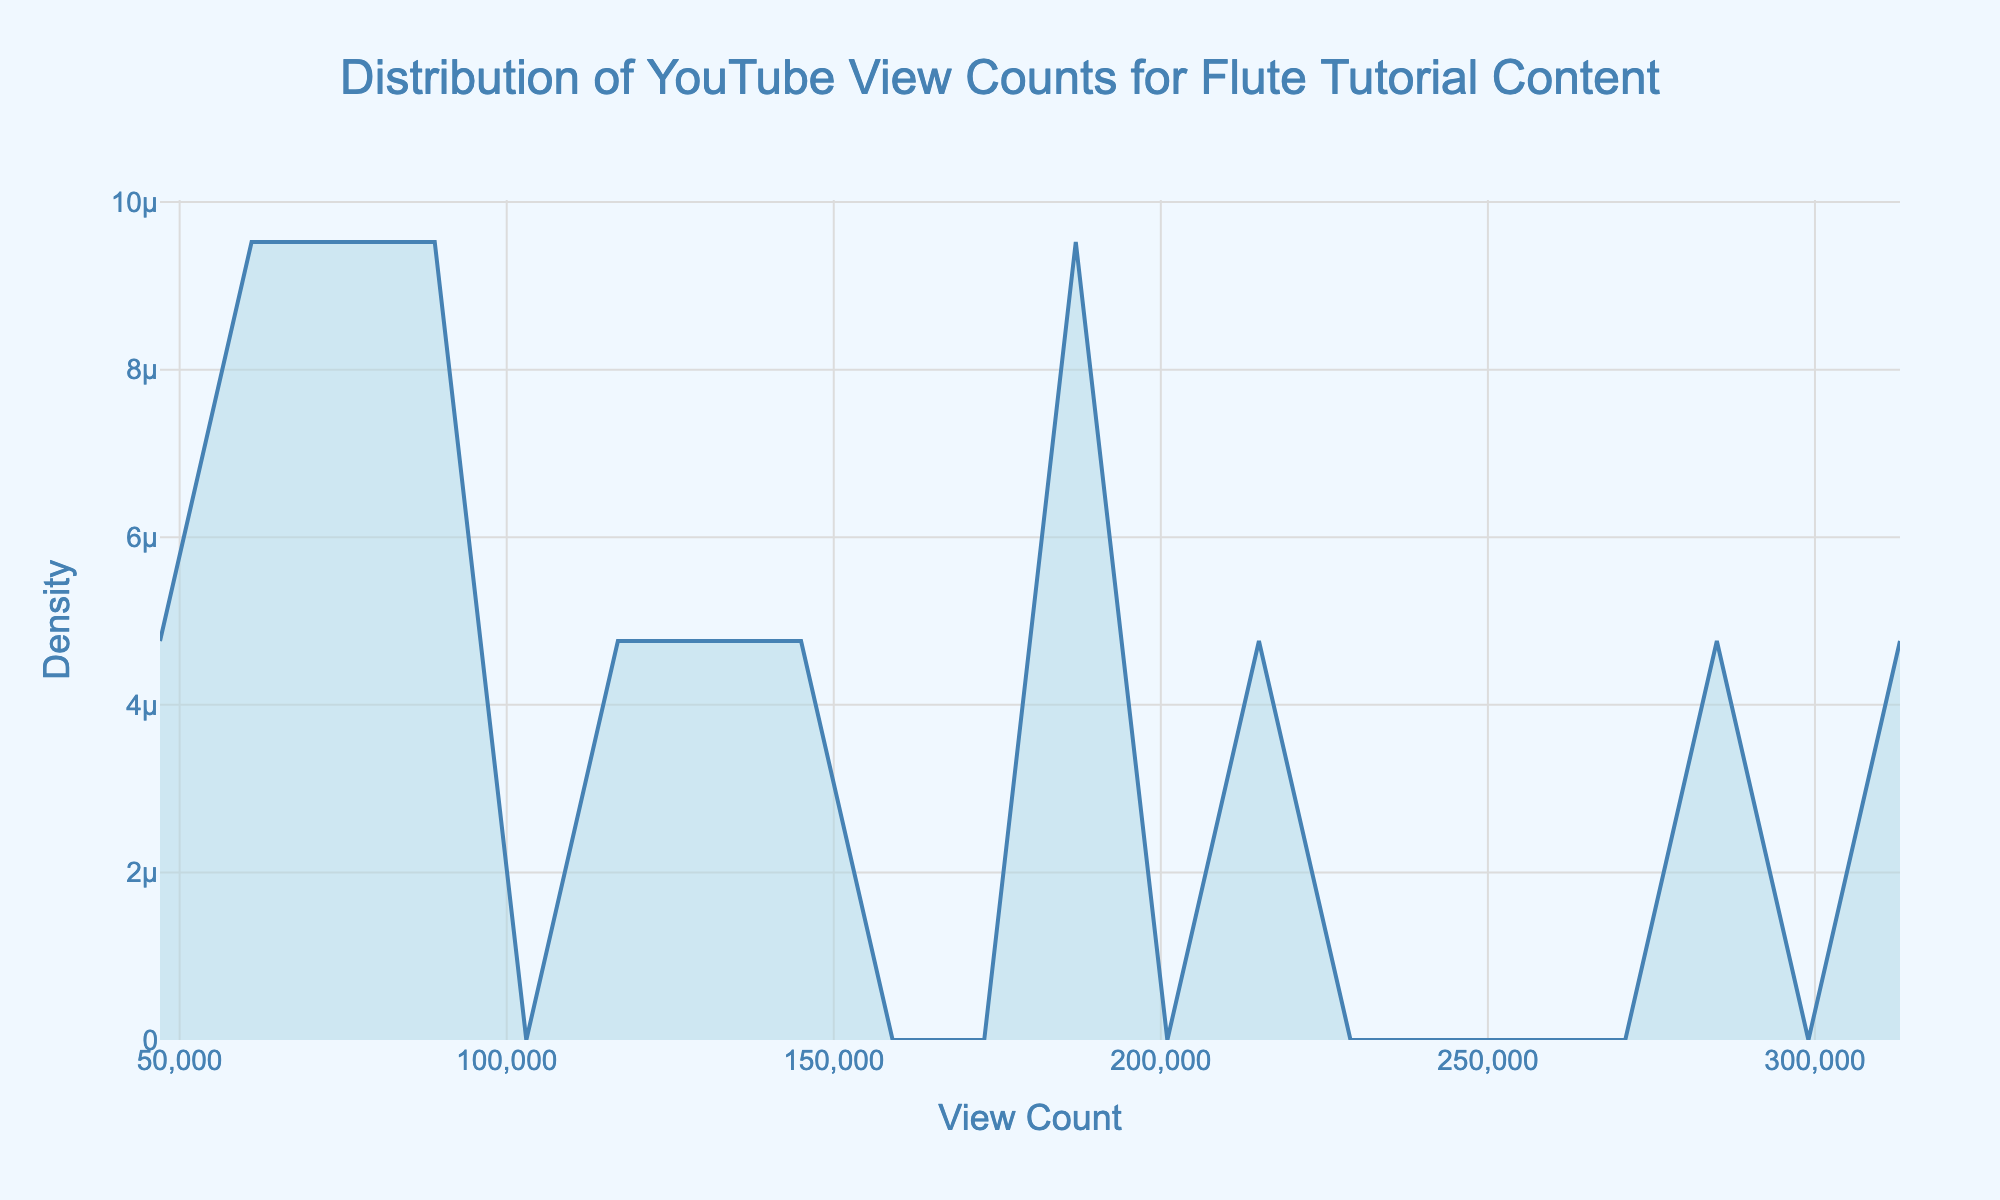What is the title of the plot? The title is located at the top center of the figure and is often the first text element you see. It gives a summary of what the plot is about.
Answer: Distribution of YouTube View Counts for Flute Tutorial Content What are the labels of the axes? The axes labels are found next to the horizontal (x-axis) and vertical (y-axis) axes and describe the data they represent. The x-axis represents 'View Count' and the y-axis represents 'Density'.
Answer: View Count; Density What color fills the area under the density curve? The color of the fill can be identified by looking directly at the area under the density curve. It is a light blue shade.
Answer: Light blue At which view count does the density curve have its peak? The peak of the density curve represents the point with the highest density. By looking at the x-axis value directly below the highest point of the curve, we can find this value. It is around 260,000 views.
Answer: Around 260,000 views How does the density for view counts of 60,000 compare to those of 200,000? To answer this, we compare the height of the density curve at 60,000 views and 200,000 views. The density at 200,000 views is higher than at 60,000 views, indicating more videos have around 200,000 views.
Answer: Higher at 200,000 Is there a range of view counts where the density is consistently low? Look for sections of the plot where the density curve stays close to the bottom without rising much. This can be observed from around 0 to 50,000 views where the curve is low.
Answer: Around 0 to 50,000 views Between which two view counts does the curve rise the most steeply? To determine where the curve rises most steeply, look for the part of the curve where it increases rapidly. This occurs between roughly 50,000 and 200,000 views.
Answer: Between 50,000 and 200,000 views How many distinct peaks are there in the density curve? Peaks are the highest points in sections of the curve. By visually examining the curve, we can see that there is one main peak around 260,000 views and a smaller peak around 100,000 views.
Answer: Two peaks 